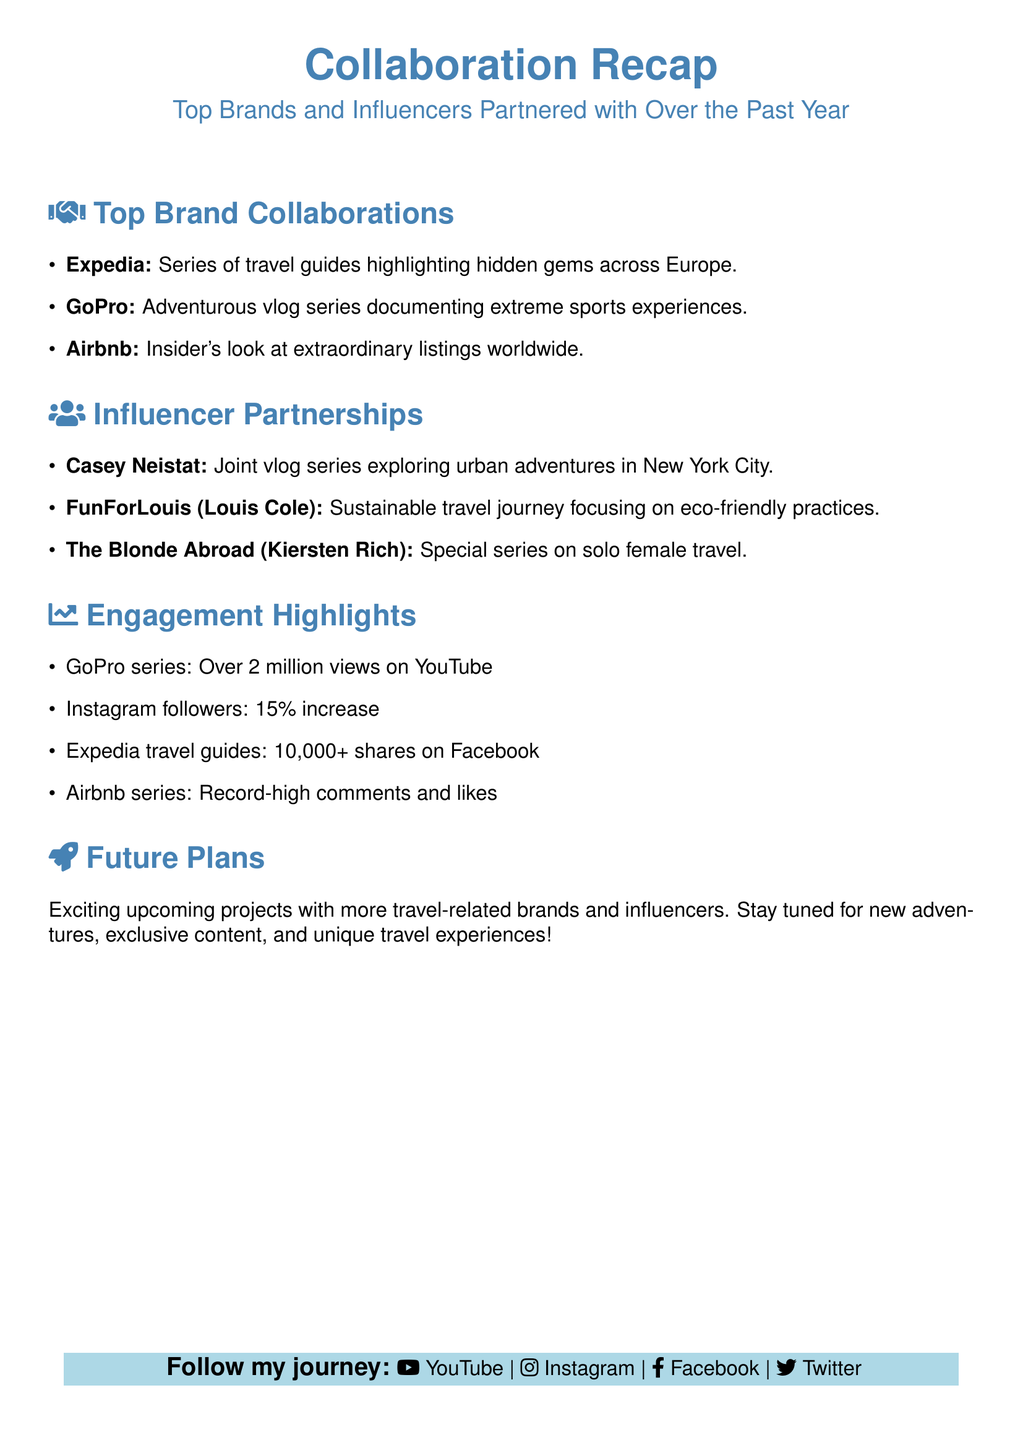What is one of the brands you've collaborated with? The document lists several brands partnered with, including Expedia.
Answer: Expedia How many views did the GoPro series achieve? The document states that the GoPro series received over 2 million views on YouTube.
Answer: 2 million What is a key focus of the travel journey with FunForLouis? The document mentions that the focus is on eco-friendly practices.
Answer: Eco-friendly practices Which influencer was involved in a joint vlog series exploring urban adventures in New York City? The document indicates that Casey Neistat partnered for a joint vlog series.
Answer: Casey Neistat What was the percentage increase in Instagram followers? According to the document, Instagram followers increased by 15 percent.
Answer: 15% What type of content can followers expect in future plans? The document suggests that followers can expect exciting travel-related projects and unique experiences.
Answer: Travel-related projects Which travel brand's guides received over 10,000 shares on Facebook? The document specifies that the Expedia travel guides had over 10,000 shares.
Answer: Expedia What type of series did The Blonde Abroad create? The document indicates that the series focused on solo female travel.
Answer: Solo female travel How did the Airbnb series perform in terms of engagement? The document states that the Airbnb series had record-high comments and likes.
Answer: Record-high comments and likes 